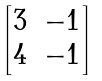Convert formula to latex. <formula><loc_0><loc_0><loc_500><loc_500>\begin{bmatrix} 3 & - 1 \\ 4 & - 1 \end{bmatrix}</formula> 